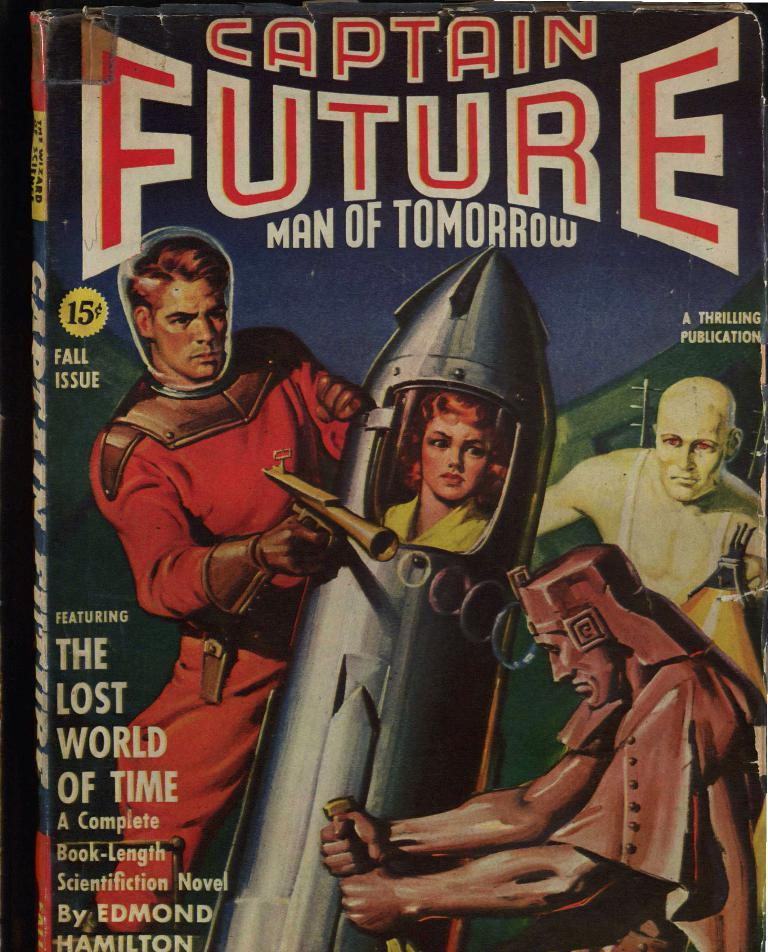<image>
Share a concise interpretation of the image provided. A book called Captain Future Man of tomorrow 